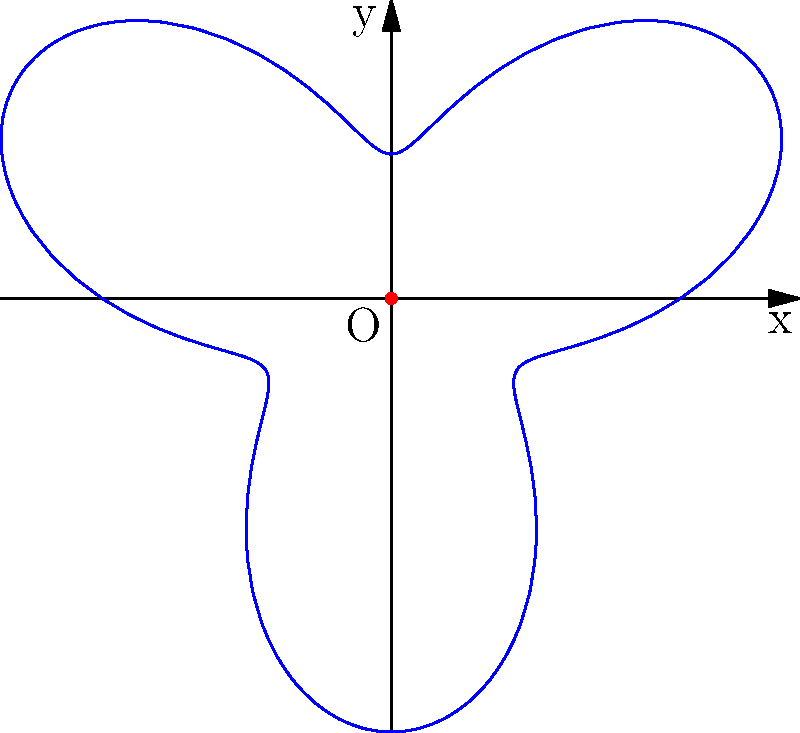In the mysterious world of Lost, the smoke monster's movement pattern is represented by the polar equation $r = 2 + \sin(3\theta)$. If the smoke monster completes one full revolution around the island, what is the total area covered by its path? To find the area covered by the smoke monster's path, we need to use the formula for the area enclosed by a polar curve:

$$A = \frac{1}{2} \int_{0}^{2\pi} r^2 d\theta$$

Where $r = 2 + \sin(3\theta)$

Step 1: Square the radius function:
$$r^2 = (2 + \sin(3\theta))^2 = 4 + 4\sin(3\theta) + \sin^2(3\theta)$$

Step 2: Integrate $r^2$ from 0 to $2\pi$:

$$A = \frac{1}{2} \int_{0}^{2\pi} (4 + 4\sin(3\theta) + \sin^2(3\theta)) d\theta$$

Step 3: Integrate each term:
- $\int_{0}^{2\pi} 4 d\theta = 4\theta |_{0}^{2\pi} = 8\pi$
- $\int_{0}^{2\pi} 4\sin(3\theta) d\theta = -\frac{4}{3}\cos(3\theta) |_{0}^{2\pi} = 0$
- $\int_{0}^{2\pi} \sin^2(3\theta) d\theta = \int_{0}^{2\pi} \frac{1-\cos(6\theta)}{2} d\theta = \frac{\theta}{2} - \frac{\sin(6\theta)}{12} |_{0}^{2\pi} = \pi$

Step 4: Sum up the results and multiply by $\frac{1}{2}$:

$$A = \frac{1}{2} (8\pi + 0 + \pi) = \frac{9\pi}{2}$$

Therefore, the total area covered by the smoke monster's path is $\frac{9\pi}{2}$ square units.
Answer: $\frac{9\pi}{2}$ square units 